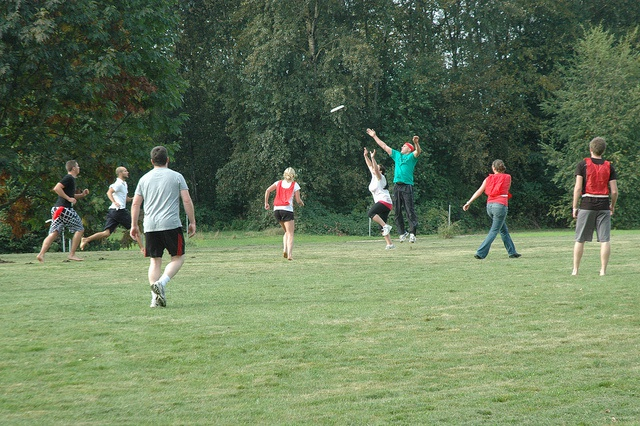Describe the objects in this image and their specific colors. I can see people in black, white, darkgray, and gray tones, people in black, gray, darkgray, and brown tones, people in black, salmon, teal, and gray tones, people in black, gray, teal, and turquoise tones, and people in black, gray, and darkgray tones in this image. 